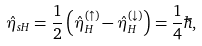Convert formula to latex. <formula><loc_0><loc_0><loc_500><loc_500>\hat { \eta } _ { s H } = \frac { 1 } { 2 } \left ( \hat { \eta } _ { H } ^ { ( \uparrow ) } - \hat { \eta } _ { H } ^ { ( \downarrow ) } \right ) = \frac { 1 } { 4 } \hbar { , }</formula> 